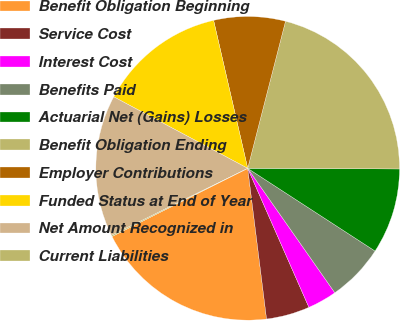<chart> <loc_0><loc_0><loc_500><loc_500><pie_chart><fcel>Benefit Obligation Beginning<fcel>Service Cost<fcel>Interest Cost<fcel>Benefits Paid<fcel>Actuarial Net (Gains) Losses<fcel>Benefit Obligation Ending<fcel>Employer Contributions<fcel>Funded Status at End of Year<fcel>Net Amount Recognized in<fcel>Current Liabilities<nl><fcel>19.57%<fcel>4.62%<fcel>3.12%<fcel>6.11%<fcel>9.1%<fcel>21.06%<fcel>7.61%<fcel>13.59%<fcel>15.08%<fcel>0.13%<nl></chart> 